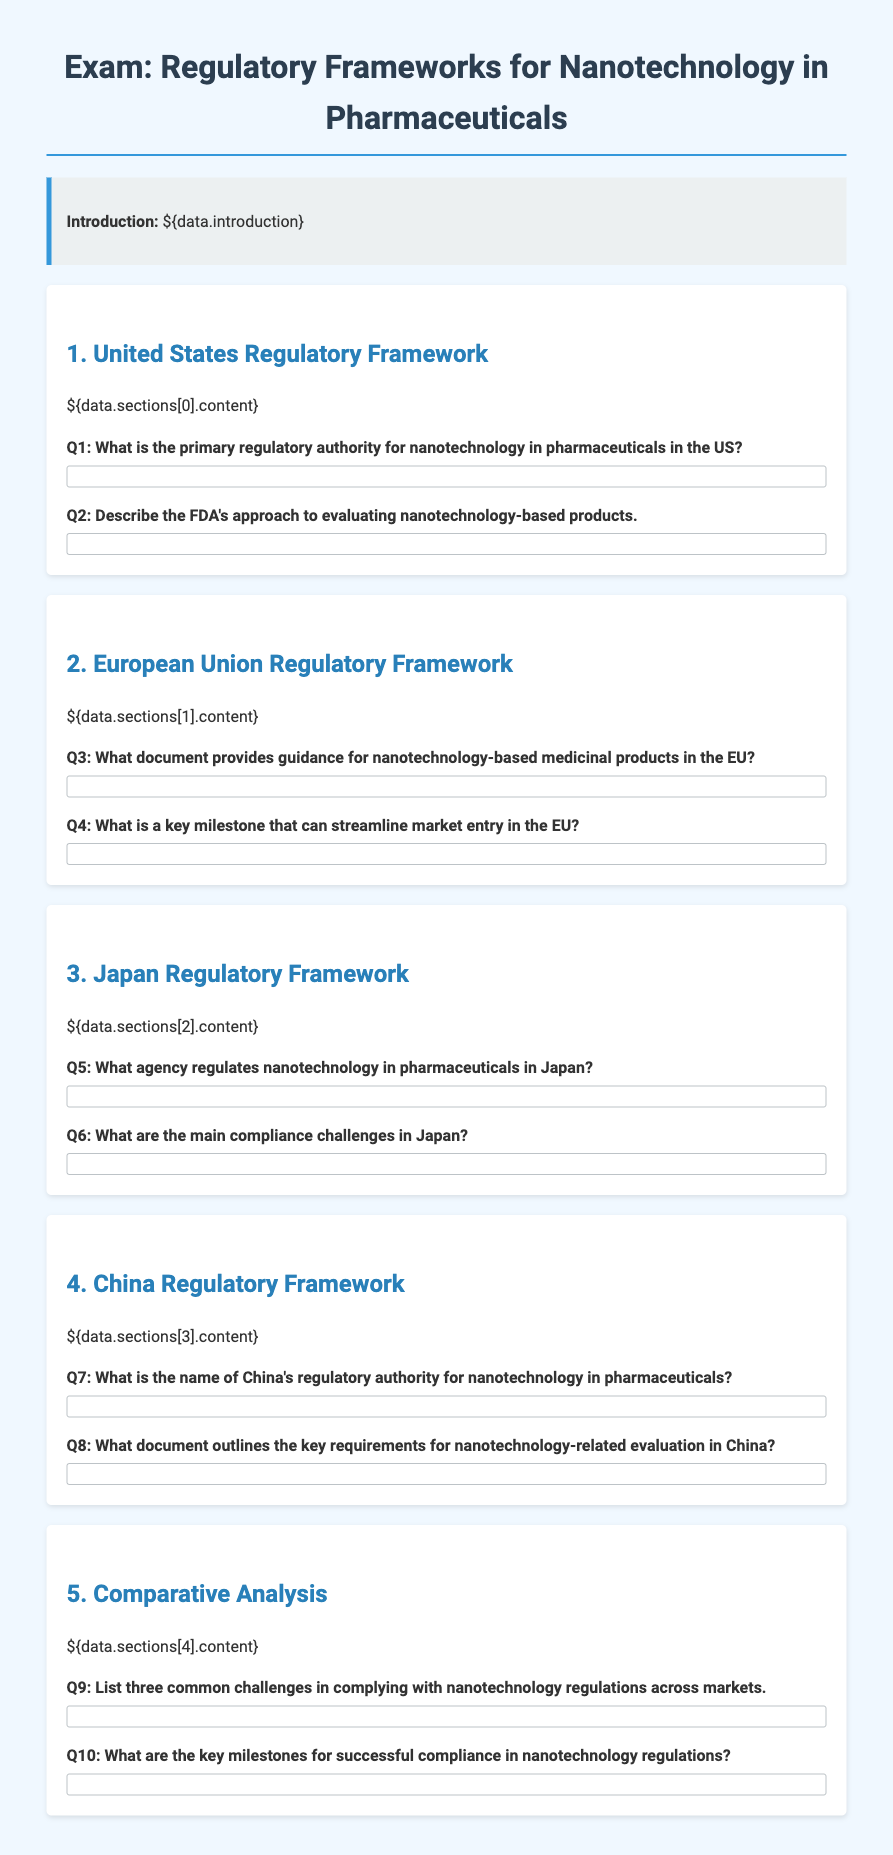What is the primary regulatory authority for nanotechnology in pharmaceuticals in the US? The primary regulatory authority for nanotechnology in pharmaceuticals in the US is the FDA.
Answer: FDA What document provides guidance for nanotechnology-based medicinal products in the EU? The document that provides guidance for nanotechnology-based medicinal products in the EU is the Guidance on the Risk Assessment of the Application of Nanoscience and Nanotechnologies in Food and Feed.
Answer: Guidance on the Risk Assessment of the Application of Nanoscience and Nanotechnologies in Food and Feed What agency regulates nanotechnology in pharmaceuticals in Japan? The agency that regulates nanotechnology in pharmaceuticals in Japan is the PMDA.
Answer: PMDA What is the name of China's regulatory authority for nanotechnology in pharmaceuticals? The name of China's regulatory authority for nanotechnology in pharmaceuticals is NMPA.
Answer: NMPA List three common challenges in complying with nanotechnology regulations across markets. The common challenges include diverse definitions of nanomaterials, varying evaluation processes, and insufficient harmonization of regulatory practices.
Answer: diverse definitions, varying evaluation processes, insufficient harmonization What are the key milestones for successful compliance in nanotechnology regulations? Key milestones include developing a robust risk assessment framework, establishing clear guidelines, and fostering international collaborations.
Answer: developing a robust risk assessment framework, establishing clear guidelines, fostering international collaborations 